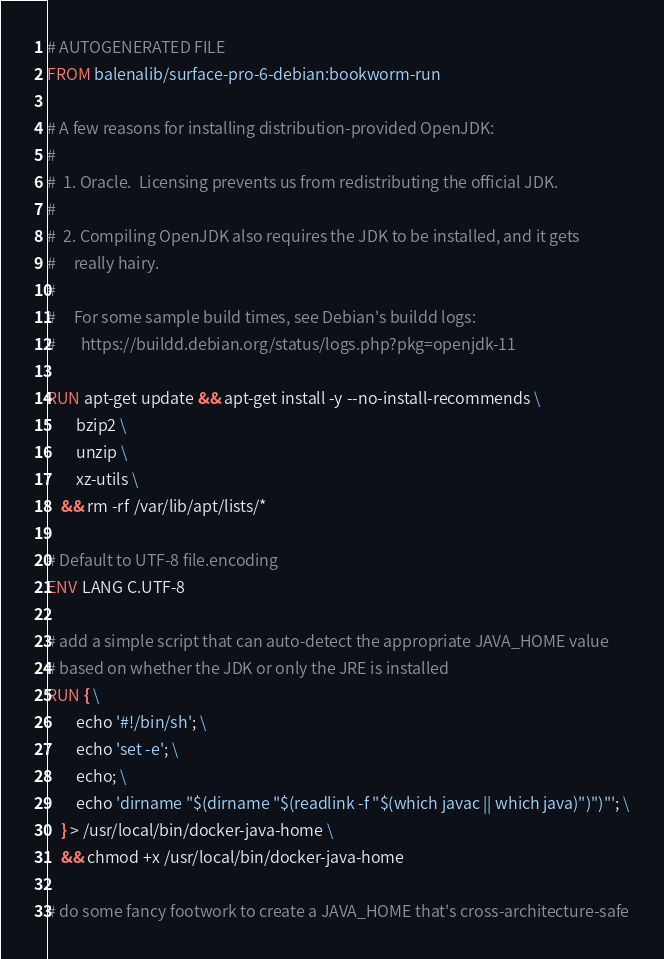Convert code to text. <code><loc_0><loc_0><loc_500><loc_500><_Dockerfile_># AUTOGENERATED FILE
FROM balenalib/surface-pro-6-debian:bookworm-run

# A few reasons for installing distribution-provided OpenJDK:
#
#  1. Oracle.  Licensing prevents us from redistributing the official JDK.
#
#  2. Compiling OpenJDK also requires the JDK to be installed, and it gets
#     really hairy.
#
#     For some sample build times, see Debian's buildd logs:
#       https://buildd.debian.org/status/logs.php?pkg=openjdk-11

RUN apt-get update && apt-get install -y --no-install-recommends \
		bzip2 \
		unzip \
		xz-utils \
	&& rm -rf /var/lib/apt/lists/*

# Default to UTF-8 file.encoding
ENV LANG C.UTF-8

# add a simple script that can auto-detect the appropriate JAVA_HOME value
# based on whether the JDK or only the JRE is installed
RUN { \
		echo '#!/bin/sh'; \
		echo 'set -e'; \
		echo; \
		echo 'dirname "$(dirname "$(readlink -f "$(which javac || which java)")")"'; \
	} > /usr/local/bin/docker-java-home \
	&& chmod +x /usr/local/bin/docker-java-home

# do some fancy footwork to create a JAVA_HOME that's cross-architecture-safe</code> 